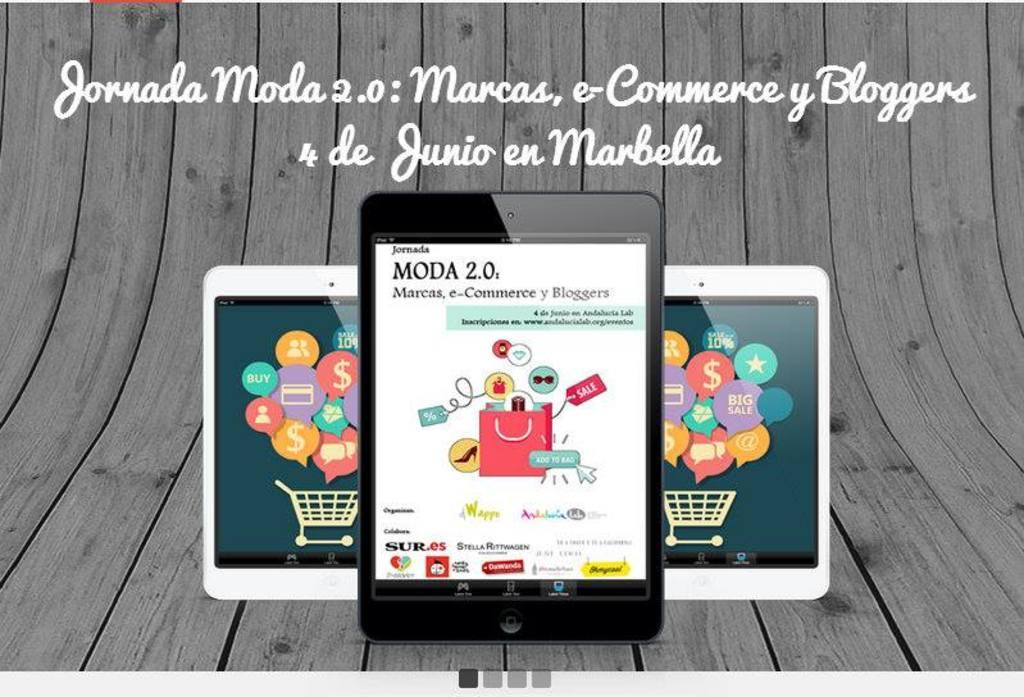What type of image is the subject of the conversation? The image is a poster. What objects can be seen in the poster? There are tablets visible in the poster. Is there any additional feature on the poster? Yes, there is a watermark on the poster. What type of roof can be seen on the bag in the image? There is no bag or roof present in the image; it only features a poster with tablets and a watermark. 